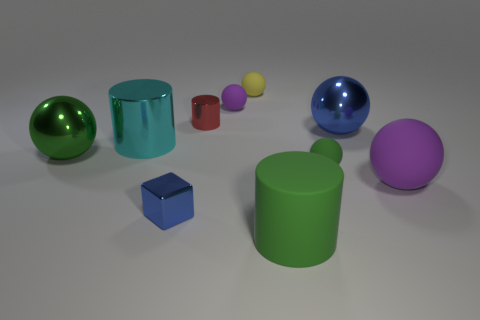Is there any other thing that has the same shape as the tiny blue shiny thing?
Keep it short and to the point. No. How many big blue spheres have the same material as the big cyan thing?
Your answer should be very brief. 1. Are there fewer big spheres than rubber things?
Make the answer very short. Yes. Does the big cylinder to the right of the tiny red metal cylinder have the same material as the tiny green ball?
Keep it short and to the point. Yes. How many blocks are yellow shiny things or tiny matte things?
Give a very brief answer. 0. What shape is the tiny object that is both on the right side of the tiny purple rubber ball and behind the small shiny cylinder?
Provide a short and direct response. Sphere. The tiny shiny thing in front of the object right of the large metal thing that is on the right side of the big rubber cylinder is what color?
Provide a succinct answer. Blue. Are there fewer big cylinders in front of the large green cylinder than tiny shiny cylinders?
Your answer should be compact. Yes. Does the tiny metal object that is to the left of the small red metal cylinder have the same shape as the tiny red metallic object in front of the small yellow rubber ball?
Offer a terse response. No. What number of objects are matte objects behind the large blue shiny thing or tiny blue metallic cubes?
Your answer should be very brief. 3. 